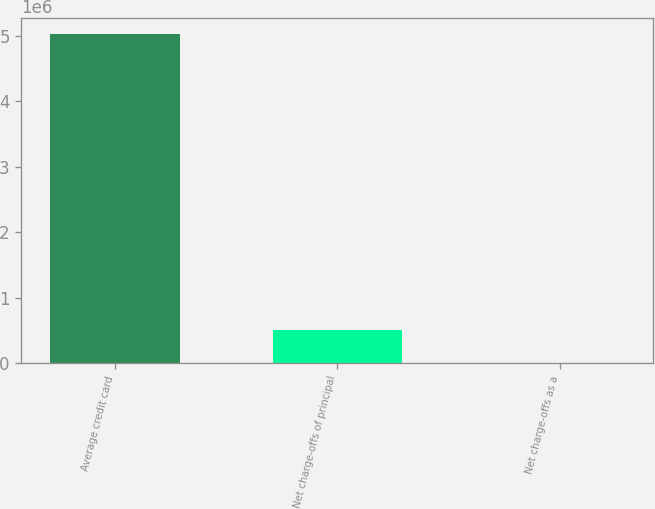Convert chart. <chart><loc_0><loc_0><loc_500><loc_500><bar_chart><fcel>Average credit card<fcel>Net charge-offs of principal<fcel>Net charge-offs as a<nl><fcel>5.02592e+06<fcel>502600<fcel>8.9<nl></chart> 